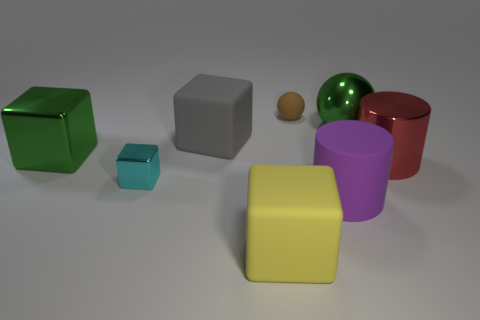Add 1 big purple cylinders. How many objects exist? 9 Subtract all cylinders. How many objects are left? 6 Add 5 cylinders. How many cylinders are left? 7 Add 4 big objects. How many big objects exist? 10 Subtract 0 blue balls. How many objects are left? 8 Subtract all blue rubber cubes. Subtract all big metallic things. How many objects are left? 5 